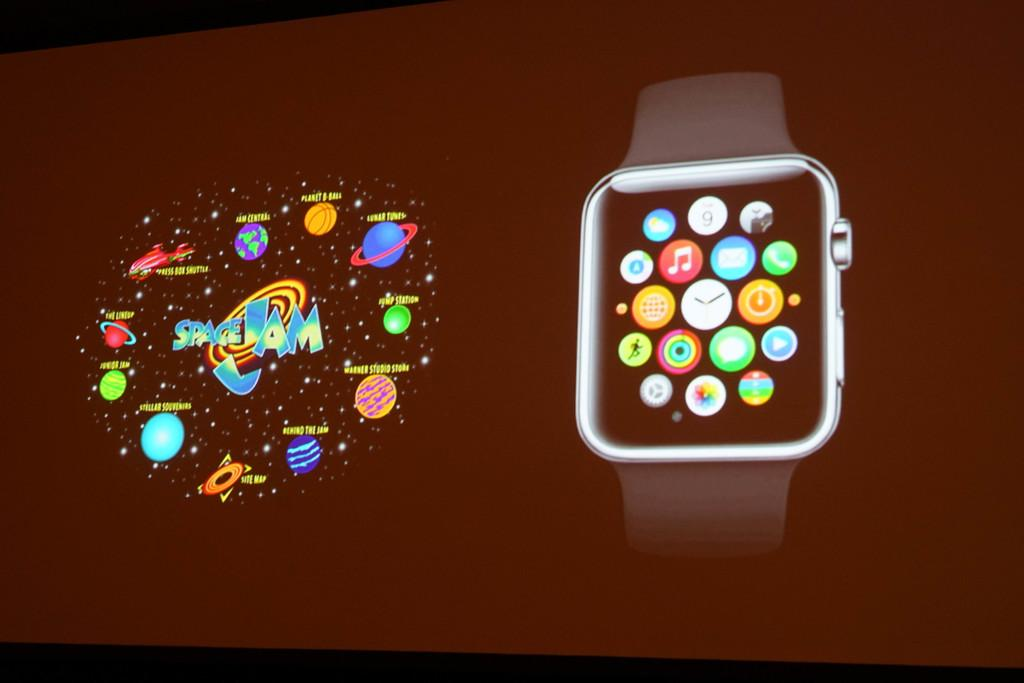<image>
Relay a brief, clear account of the picture shown. A smart watch with the space jam logo next to it. 